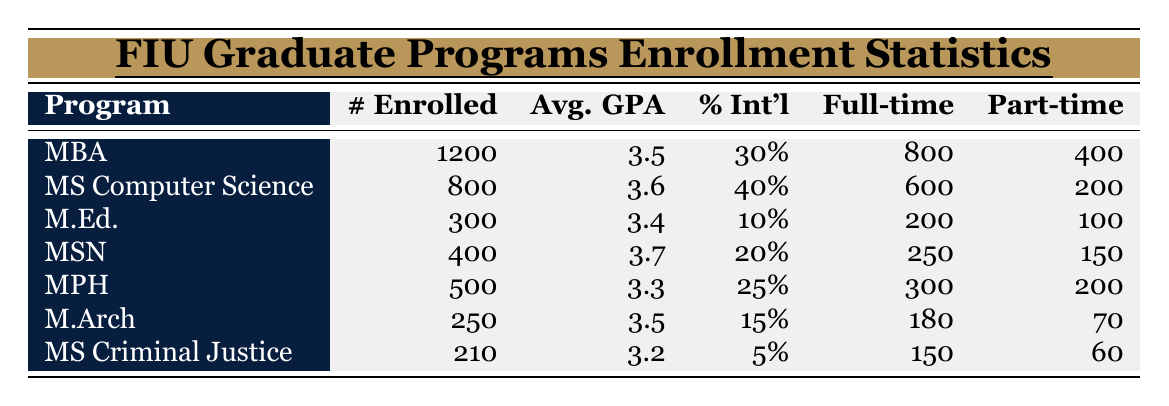What is the enrolled student count for the MBA program? The table lists the number of enrolled students for each program. According to the MBA row, there are 1200 enrolled students.
Answer: 1200 What is the average GPA of the Master of Science in Nursing program? The average GPA for each program is provided in the table, and for the Master of Science in Nursing (MSN), the average GPA is 3.7.
Answer: 3.7 What percentage of international students is enrolled in the Master of Education program? The table indicates that 10% of international students are enrolled in the Master of Education (M.Ed.) program.
Answer: 10% How many full-time students are enrolled in the Master of Public Health program? The table specifies the number of full-time students for each program, which shows that 300 full-time students are enrolled in the Master of Public Health (MPH).
Answer: 300 What is the total number of part-time students across all programs? To find the total number of part-time students, add the part-time numbers for each program: 400 (MBA) + 200 (MS Computer Science) + 100 (M.Ed.) + 150 (MSN) + 200 (MPH) + 70 (M.Arch) + 60 (MS Criminal Justice) = 1,180 part-time students.
Answer: 1180 Which program has the highest average GPA, and what is that GPA? The program with the highest average GPA can be found by comparing the average GPA values in the table. The Master of Science in Nursing (MSN) has the highest average GPA at 3.7.
Answer: Master of Science in Nursing (3.7) Is the percentage of international students in the Master of Architecture higher than that in the Master of Criminal Justice? Comparing the international student percentages, the Master of Architecture has 15% while the Master of Criminal Justice has 5%. Since 15% is greater than 5%, the Master of Architecture does have a higher percentage.
Answer: Yes What is the average number of enrolled students across all graduate programs? To calculate the average number of enrolled students, sum the enrolled students: 1200 + 800 + 300 + 400 + 500 + 250 + 210 = 3660. Then divide by the number of programs, which is 7: 3660 / 7 = 522.86, rounded to 523.
Answer: 523 Count the number of programs with less than 400 enrolled students. By reviewing the table, the programs with less than 400 enrolled students are M.Ed. (300), M.Arch (250), and MS Criminal Justice (210), totaling 3 programs.
Answer: 3 